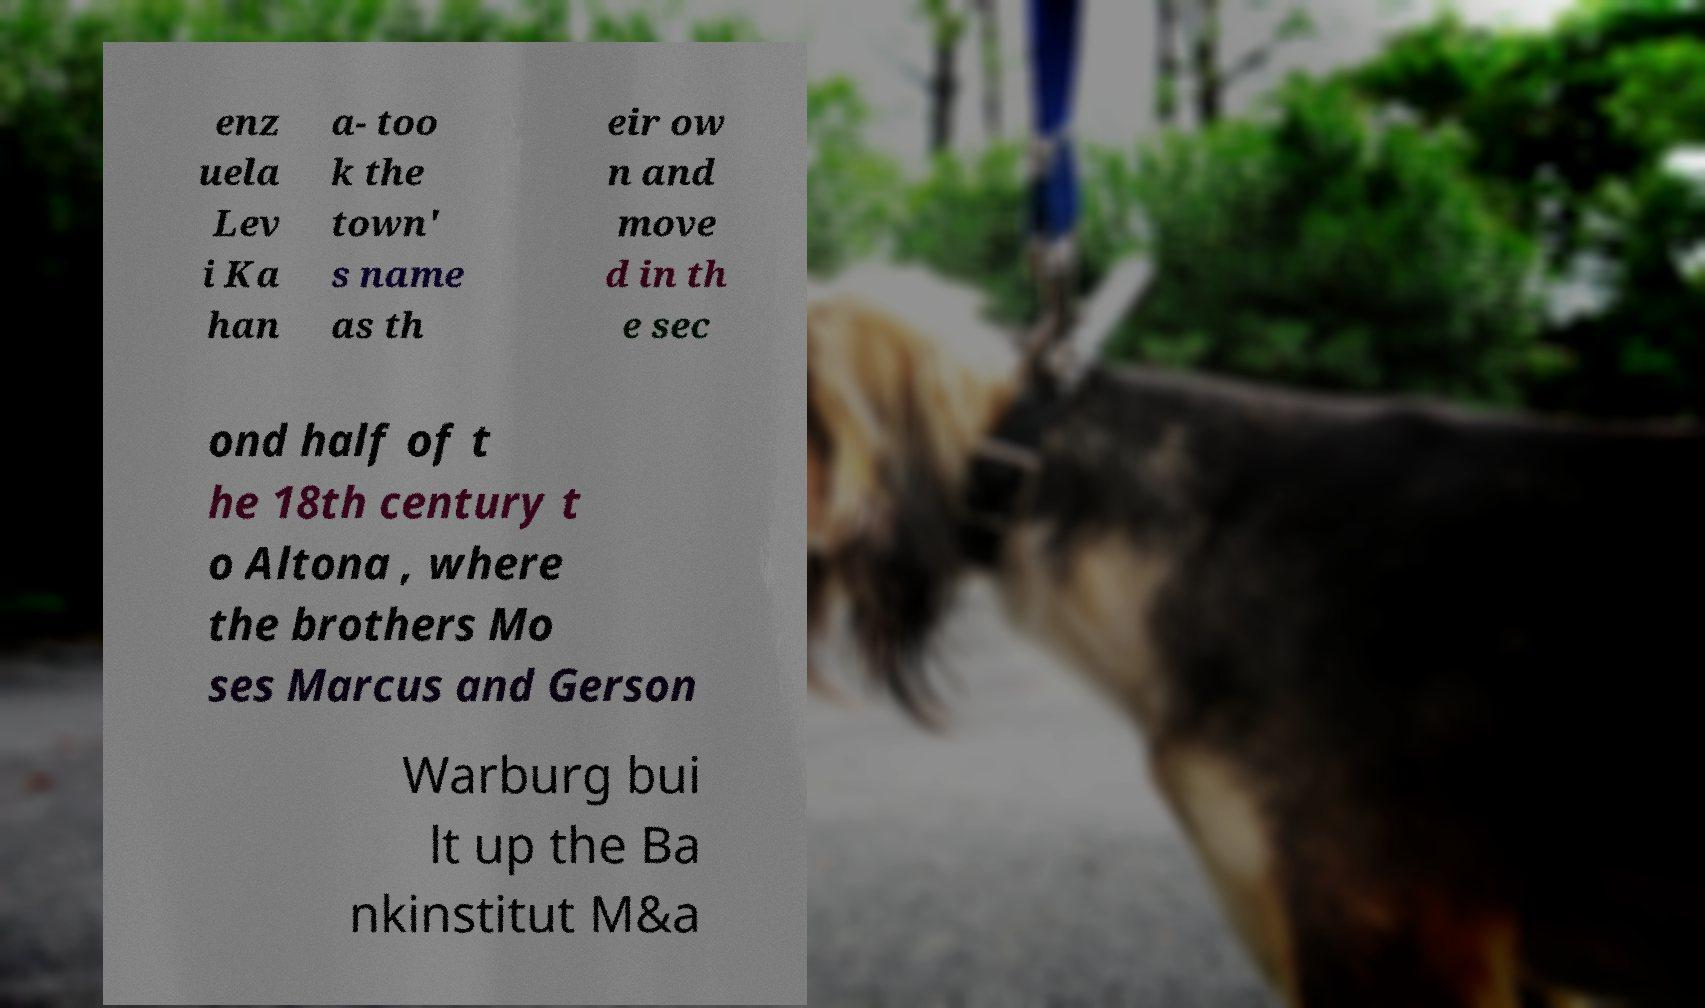Please identify and transcribe the text found in this image. enz uela Lev i Ka han a- too k the town' s name as th eir ow n and move d in th e sec ond half of t he 18th century t o Altona , where the brothers Mo ses Marcus and Gerson Warburg bui lt up the Ba nkinstitut M&a 